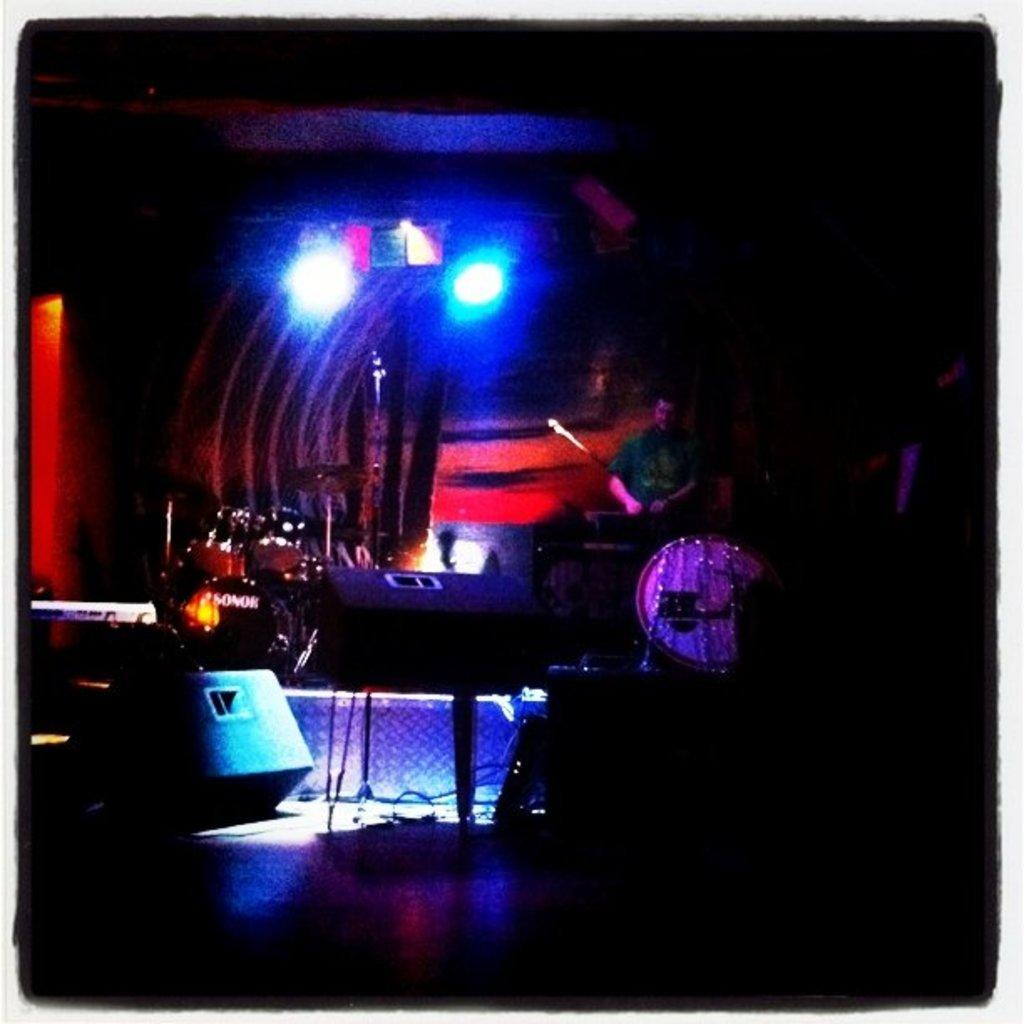What can be seen on the stage in the image? There are musical instruments and speakers on the stage. What might be used to amplify sound during a performance? The speakers on the stage might be used to amplify sound during a performance. Can you describe the person in the background of the image? There is a person in the background, but no specific details about them are provided. How are the lights arranged in the background? The lights are arranged in the background, but no specific details about their arrangement are provided. What is the color of the background in the image? The background is dark in color. What type of coil is being used to protest in the image? There is no coil or protest present in the image; it features musical instruments and speakers on a stage with a dark background. 